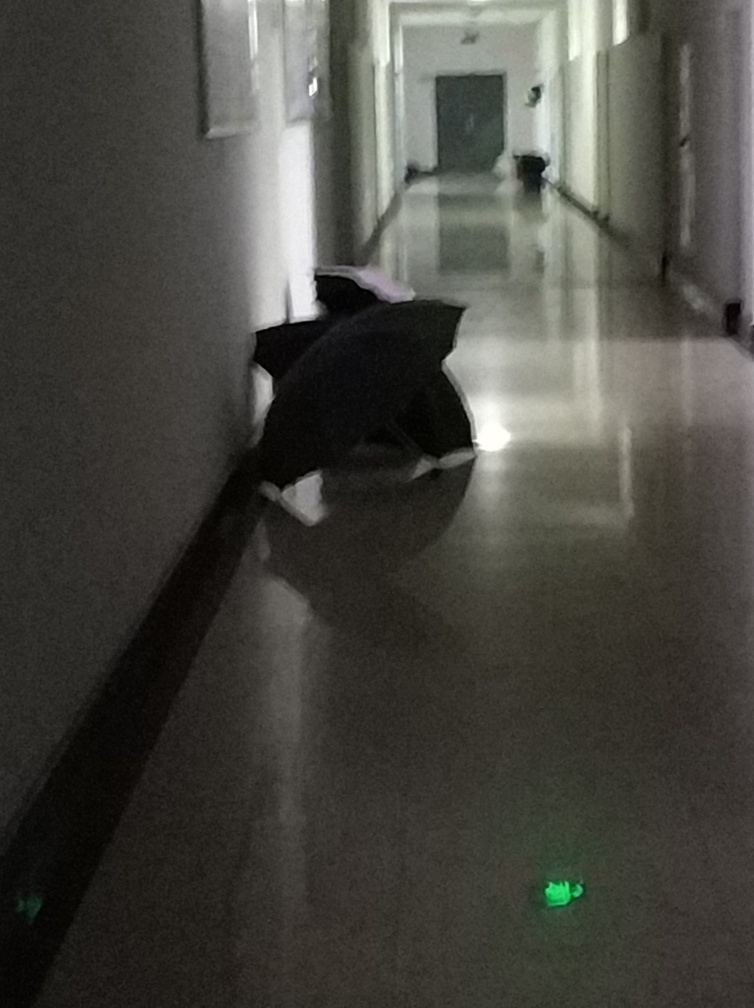What might be the reason for the umbrella being placed in the hallway? There are several possible reasons. The umbrella might have been left there momentarily by someone who stepped into an adjacent room, perhaps avoiding dripping water elsewhere. Alternatively, its placement might be intentional, serving as a barrier or sign to caution others, indicative of a wet floor or a nearby hazard not easily visible in the photo. 